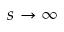<formula> <loc_0><loc_0><loc_500><loc_500>s \to \infty</formula> 